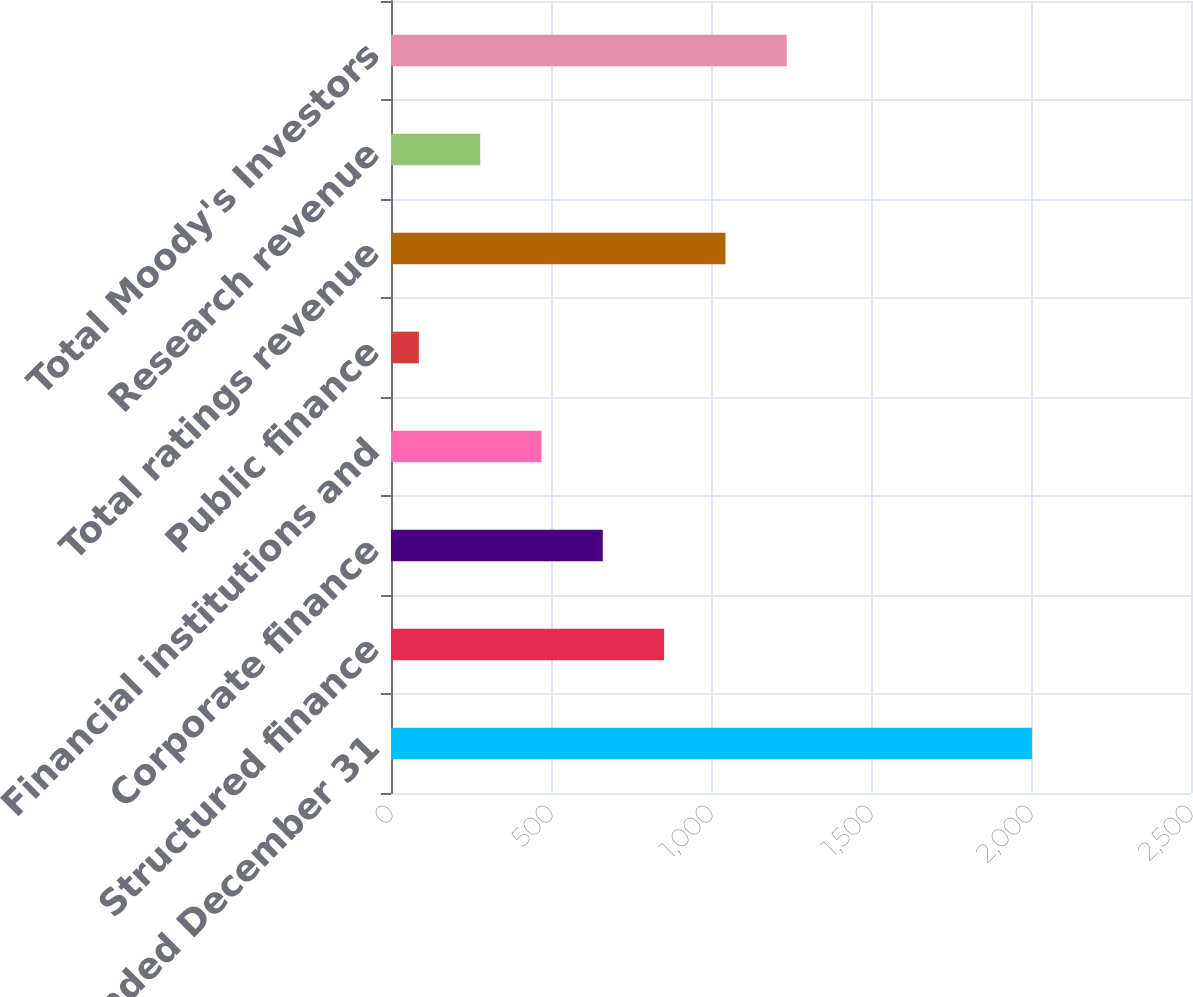Convert chart. <chart><loc_0><loc_0><loc_500><loc_500><bar_chart><fcel>Year Ended December 31<fcel>Structured finance<fcel>Corporate finance<fcel>Financial institutions and<fcel>Public finance<fcel>Total ratings revenue<fcel>Research revenue<fcel>Total Moody's Investors<nl><fcel>2003<fcel>853.52<fcel>661.94<fcel>470.36<fcel>87.2<fcel>1045.1<fcel>278.78<fcel>1236.68<nl></chart> 